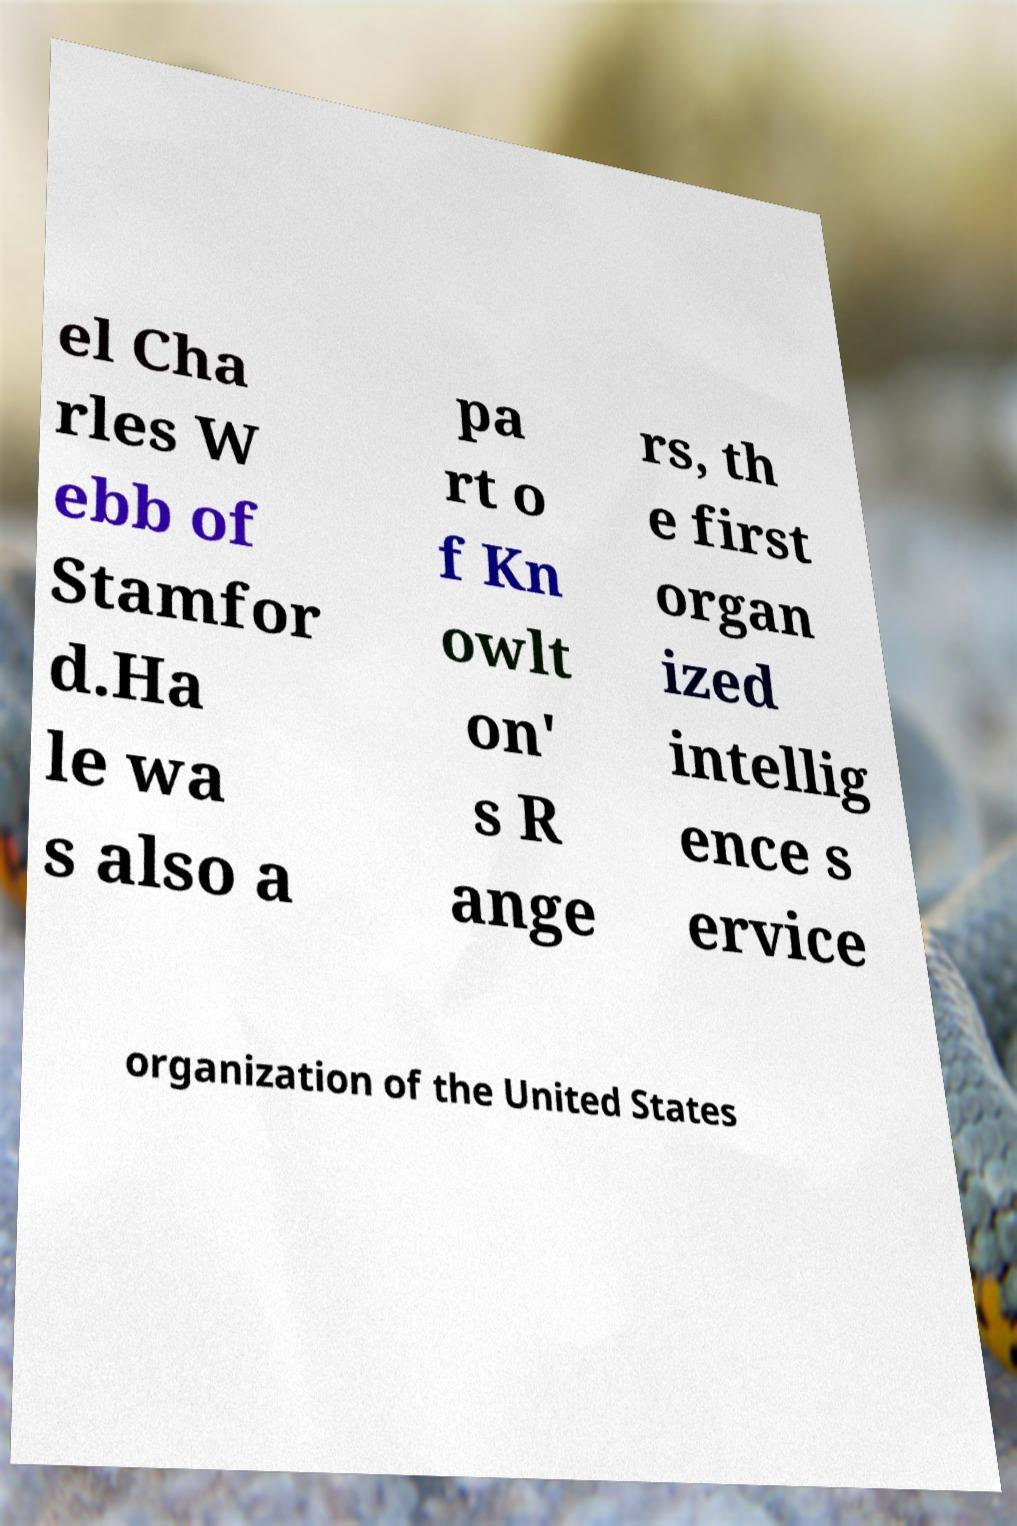What messages or text are displayed in this image? I need them in a readable, typed format. el Cha rles W ebb of Stamfor d.Ha le wa s also a pa rt o f Kn owlt on' s R ange rs, th e first organ ized intellig ence s ervice organization of the United States 